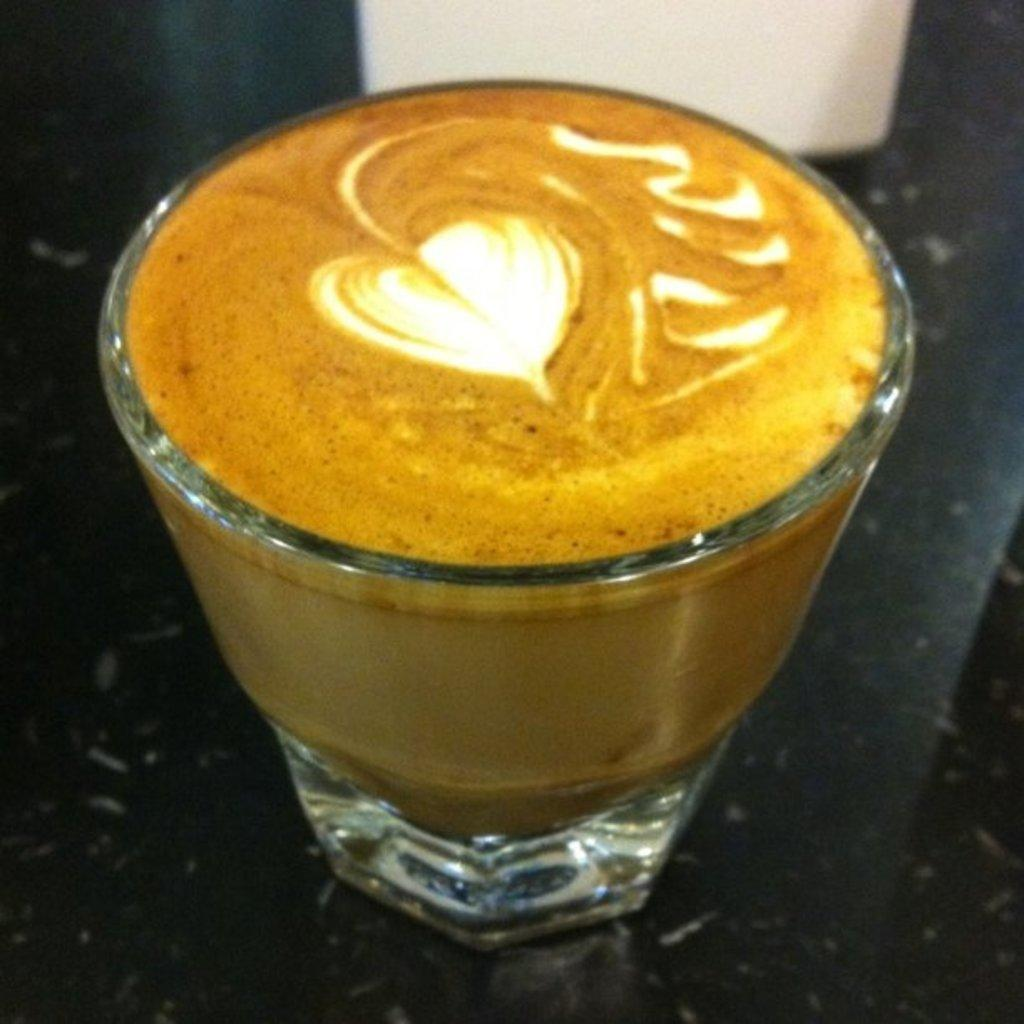What is in the glass that is visible in the image? There is a glass containing coffee in the image. What design can be seen in the coffee? A heart shape is made with cream in the coffee. What type of protest is happening in the image? There is no protest present in the image; it features a glass of coffee with a heart shape made with cream. How many hens are visible in the image? There are no hens present in the image. 